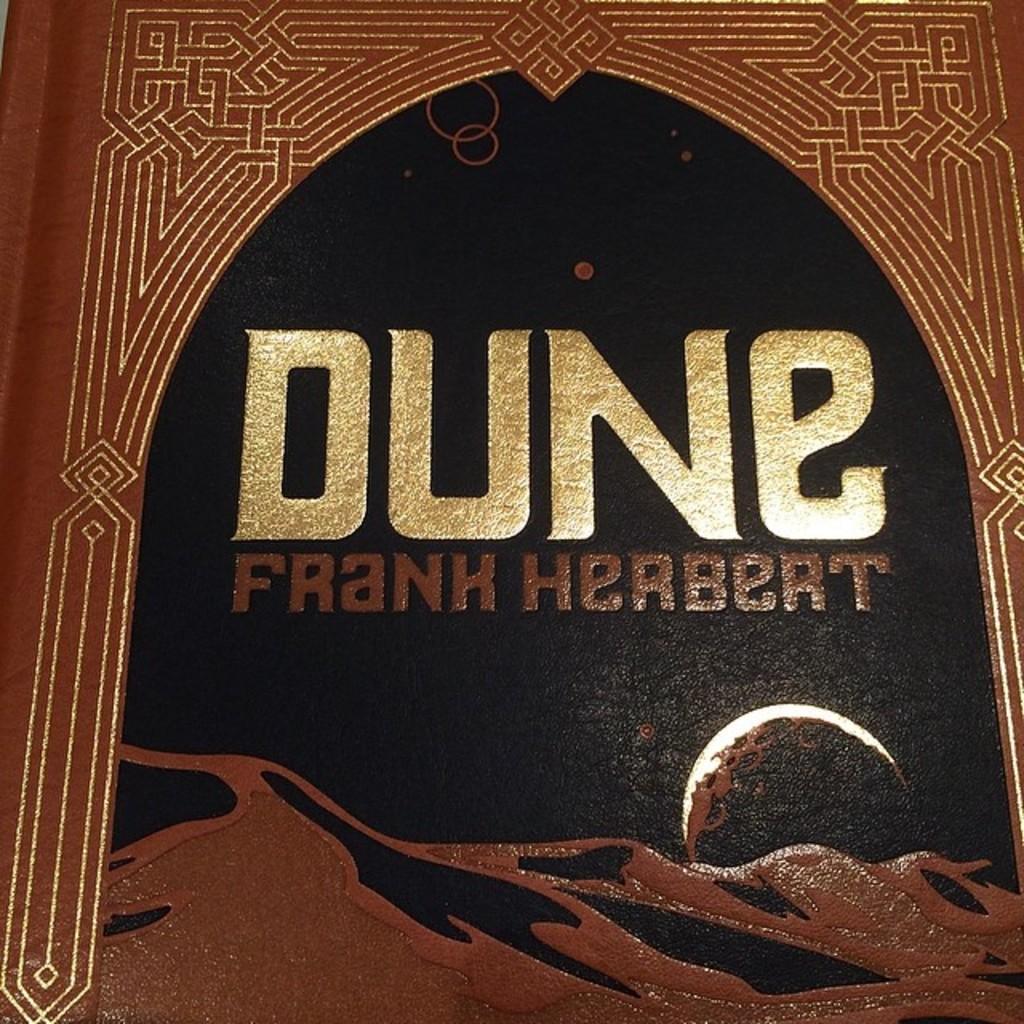Describe this image in one or two sentences. In this image it looks like a book, and on the book there is some text. 